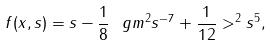<formula> <loc_0><loc_0><loc_500><loc_500>f ( x , s ) = s - \frac { 1 } { 8 } \ g m ^ { 2 } s ^ { - 7 } + \frac { 1 } { 1 2 } > ^ { 2 } s ^ { 5 } ,</formula> 